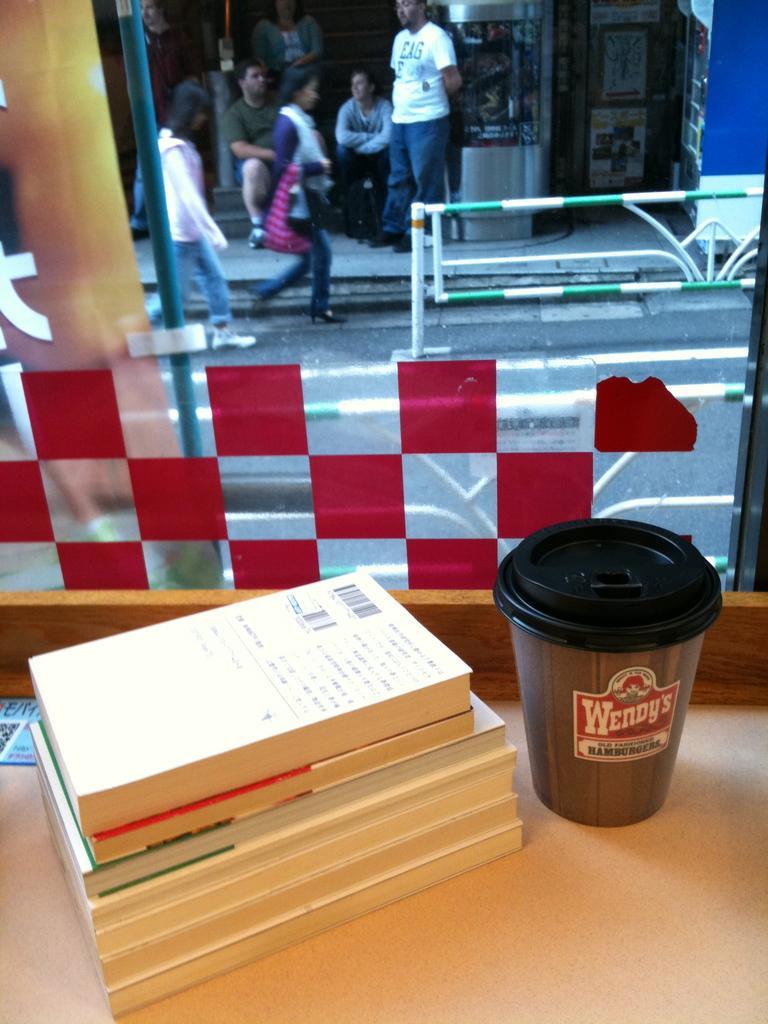Please provide a concise description of this image. Here there are books and a cup on the table at the glass door. Through the glass door we can see two women walking on the road and there are few people and two men sitting over here and we can see poles. 